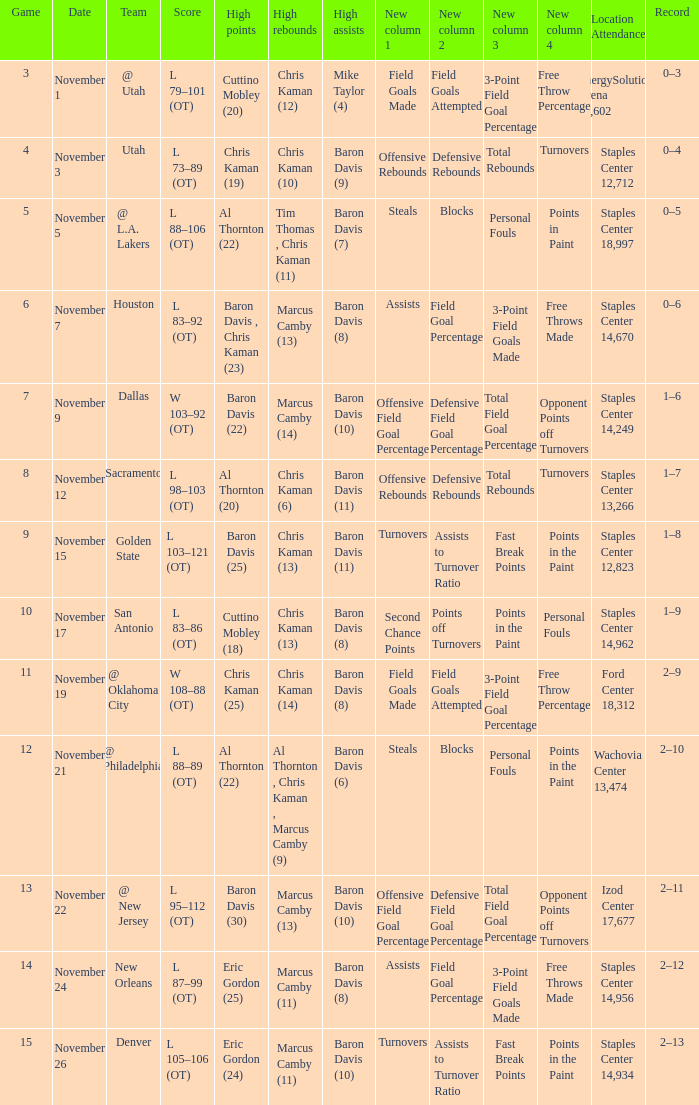Name the total number of score for staples center 13,266 1.0. 